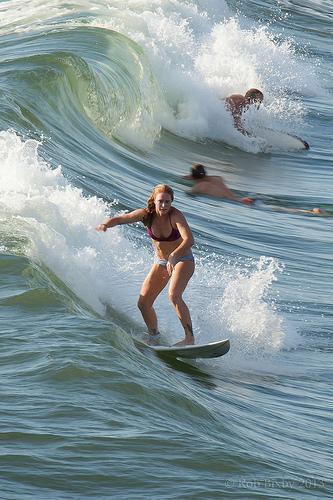How many people can be seen in the photo?
Give a very brief answer. 3. 